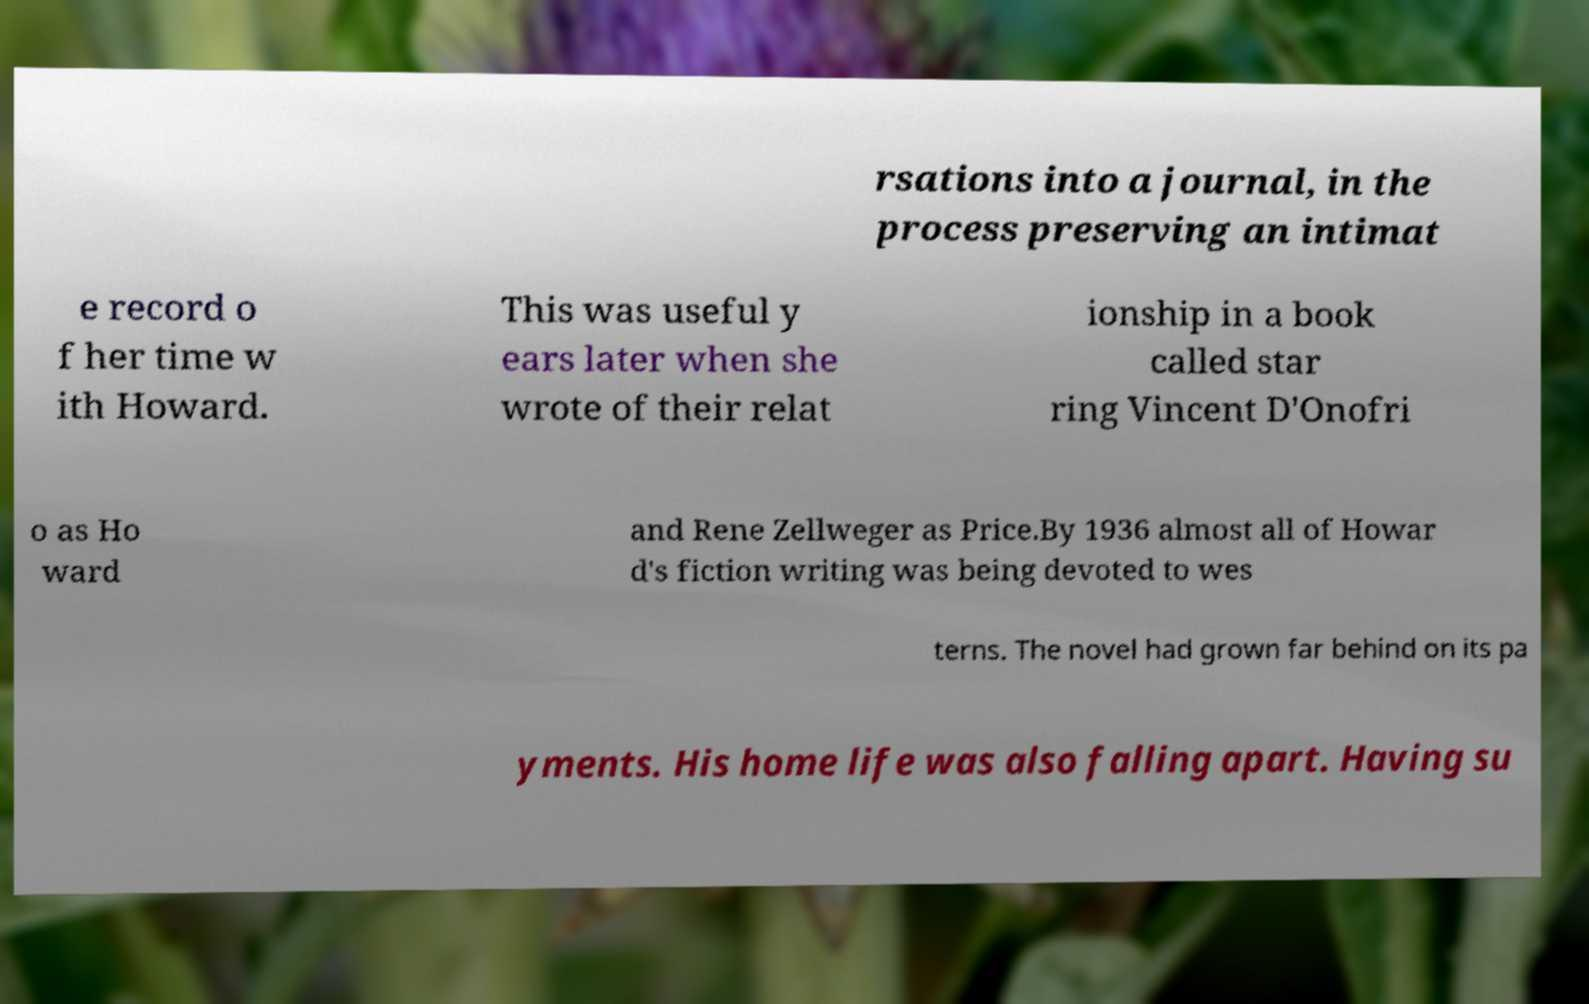There's text embedded in this image that I need extracted. Can you transcribe it verbatim? rsations into a journal, in the process preserving an intimat e record o f her time w ith Howard. This was useful y ears later when she wrote of their relat ionship in a book called star ring Vincent D'Onofri o as Ho ward and Rene Zellweger as Price.By 1936 almost all of Howar d's fiction writing was being devoted to wes terns. The novel had grown far behind on its pa yments. His home life was also falling apart. Having su 